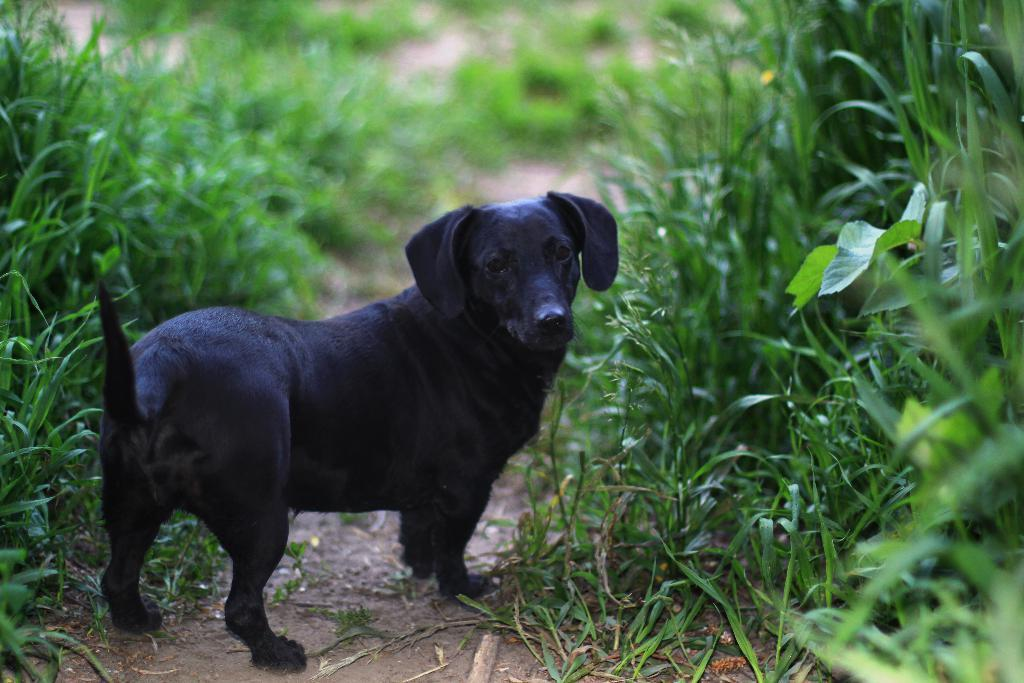What is the main feature of the image? There is a path in the image. What can be seen on the path? There is a dog on the path. What type of vegetation is present alongside the path? There is grass on either side of the path. What type of nut is being used to hold the path together? There is no mention of nuts in the image, and the path appears to be a solid surface rather than held together by any type of nut. 